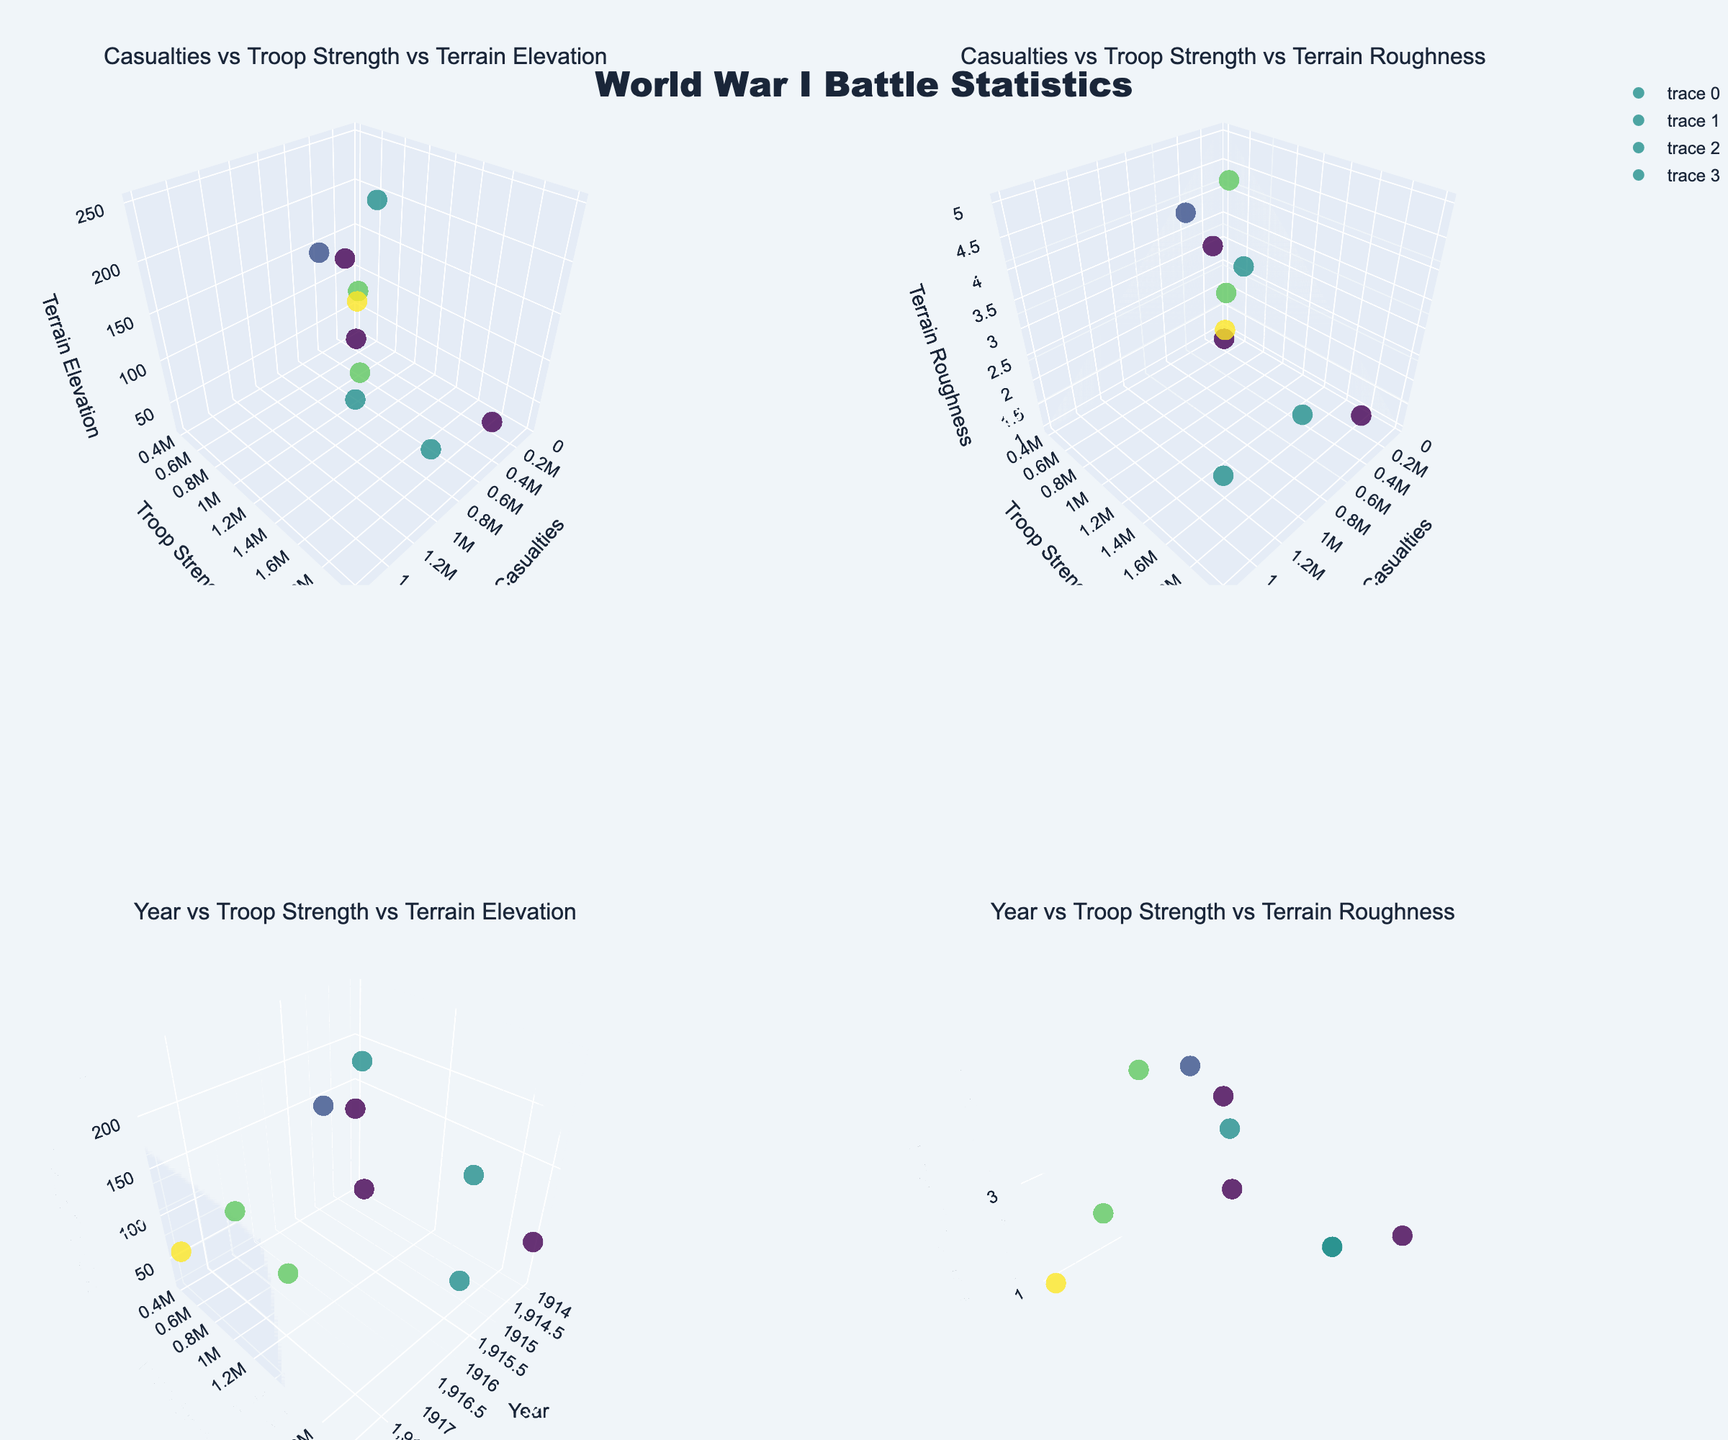What's the title of the figure? The title of the figure is usually located at the top center. In this case, it is clearly labeled "World War I Battle Statistics."
Answer: World War I Battle Statistics How many subplots are there in the figure? By visually counting the subdivisions of plots, we see the figure contains four subplots arranged in a 2x2 grid.
Answer: Four What does the color represent in the subplots? The color scale in the subplots is derived from the 'Year' data of each battle. This indicates the battles are color-coded by the year they occurred.
Answer: Year of the battle Which battle has the highest terrain elevation? By inspecting the z-axis of the first and third subplots and noting the tooltip information, Verdun has the highest terrain elevation at 250.
Answer: Verdun In which year did the battle with the least troop strength occur? Observing the third and fourth subplots, the battle with the least troop strength occurred during the Battle of Tannenberg in 1914 with 400,000 troops.
Answer: 1914 Which subplot shows the relationship between casualties, troop strength, and terrain roughness? The second subplot is the one where the x-axis represents casualties, the y-axis represents troop strength, and the z-axis represents terrain roughness, as suggested by the subplot titles.
Answer: The second subplot What is the range of years depicted in the plots? By examining the x-axes of the third and fourth subplots, the years range from the Battle of Ypres in 1914 to the Battle of Amiens in 1918.
Answer: 1914 to 1918 How does the Battle of Cambrai compare to the Battle of Somme in terms of terrain roughness? In the second and fourth subplots, Cambrai has a terrain roughness of 2, while Somme has a roughness of 3, indicating Cambrai had smoother terrain compared to Somme.
Answer: Cambrai had smoother terrain What is the approximate troop strength for the Battle of Passchendaele? Looking at the y-axis in all subplots, especially observing the corresponding scatter points, Passchendaele had around 1,000,000 troops.
Answer: 1,000,000 Which plot helps to understand the relationship between year, troop strength, and terrain elevation? The third subplot consists of the year on the x-axis, troop strength on the y-axis, and terrain elevation on the z-axis, thus showing this relationship.
Answer: The third subplot 